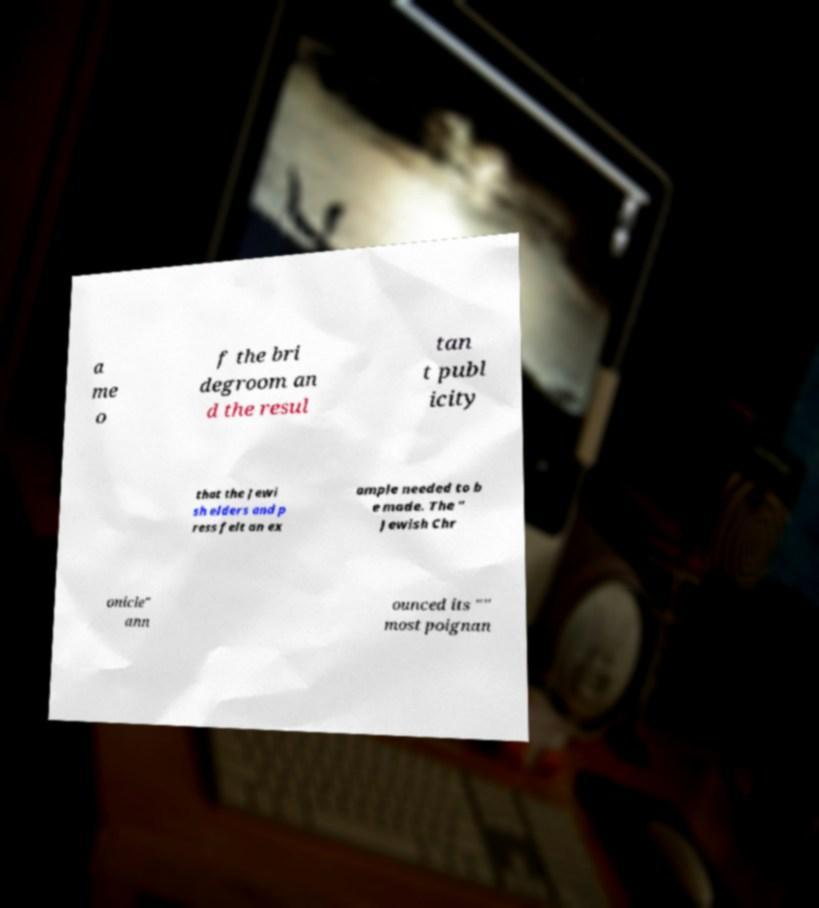Can you accurately transcribe the text from the provided image for me? a me o f the bri degroom an d the resul tan t publ icity that the Jewi sh elders and p ress felt an ex ample needed to b e made. The " Jewish Chr onicle" ann ounced its "" most poignan 